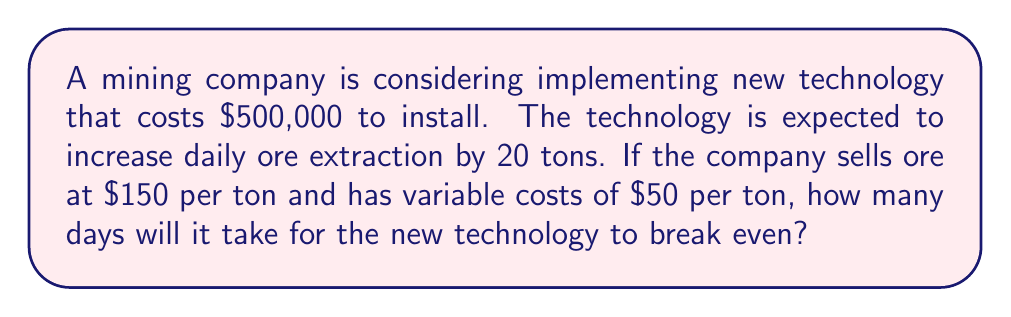Show me your answer to this math problem. Let's approach this step-by-step:

1) First, we need to calculate the additional profit per ton of ore:
   Profit per ton = Selling price - Variable costs
   $$ \text{Profit per ton} = \$150 - \$50 = \$100 $$

2) Now, we calculate the additional daily profit from the increased production:
   Daily additional profit = Additional tons × Profit per ton
   $$ \text{Daily additional profit} = 20 \times \$100 = \$2,000 $$

3) To find the break-even point, we need to determine how many days it will take for the cumulative additional profit to equal the cost of the new technology:
   $$ \text{Break-even point} \times \text{Daily additional profit} = \text{Cost of technology} $$
   $$ x \times \$2,000 = \$500,000 $$

4) Solve for x:
   $$ x = \frac{\$500,000}{\$2,000} = 250 $$

Therefore, it will take 250 days for the new technology to break even.
Answer: 250 days 